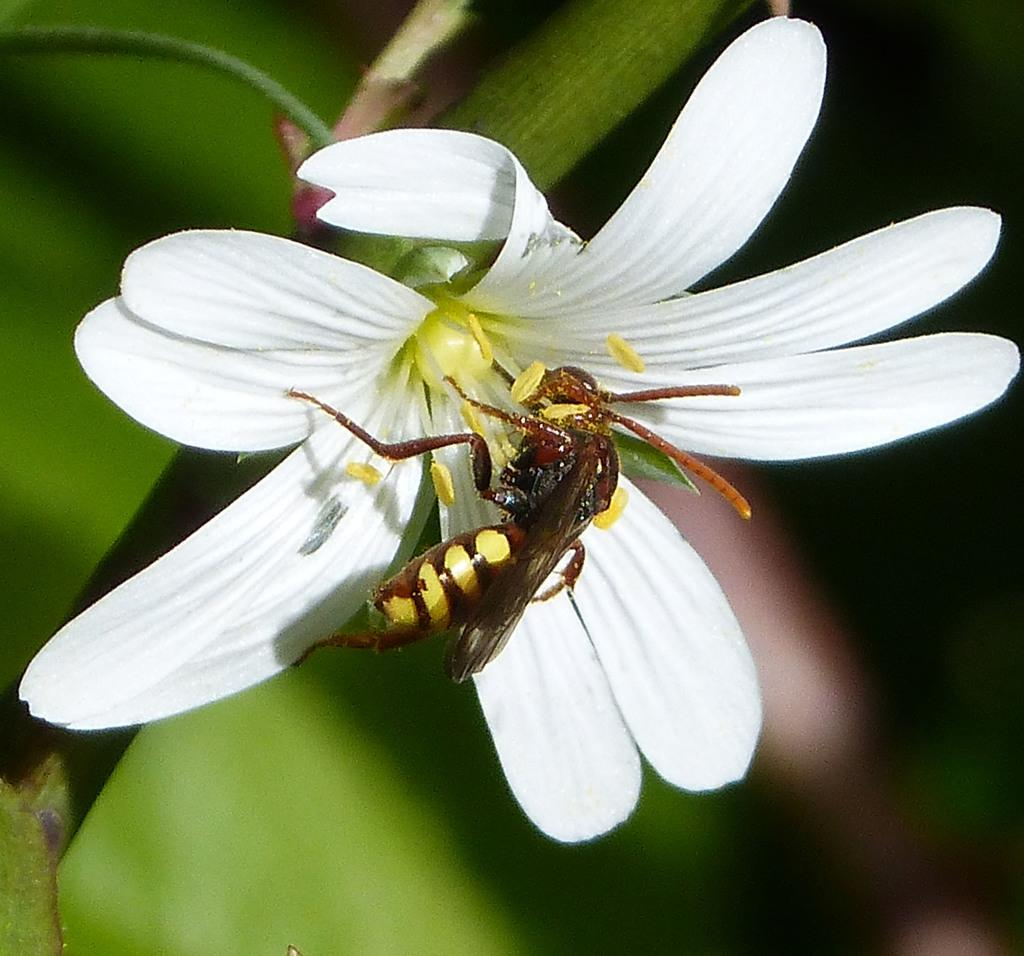What is present in the image? There is a bee in the image. Where is the bee located? The bee is on a flower. What type of pleasure does the queen experience while observing the bee in the image? There is no queen present in the image, and therefore no pleasure can be attributed to her. 